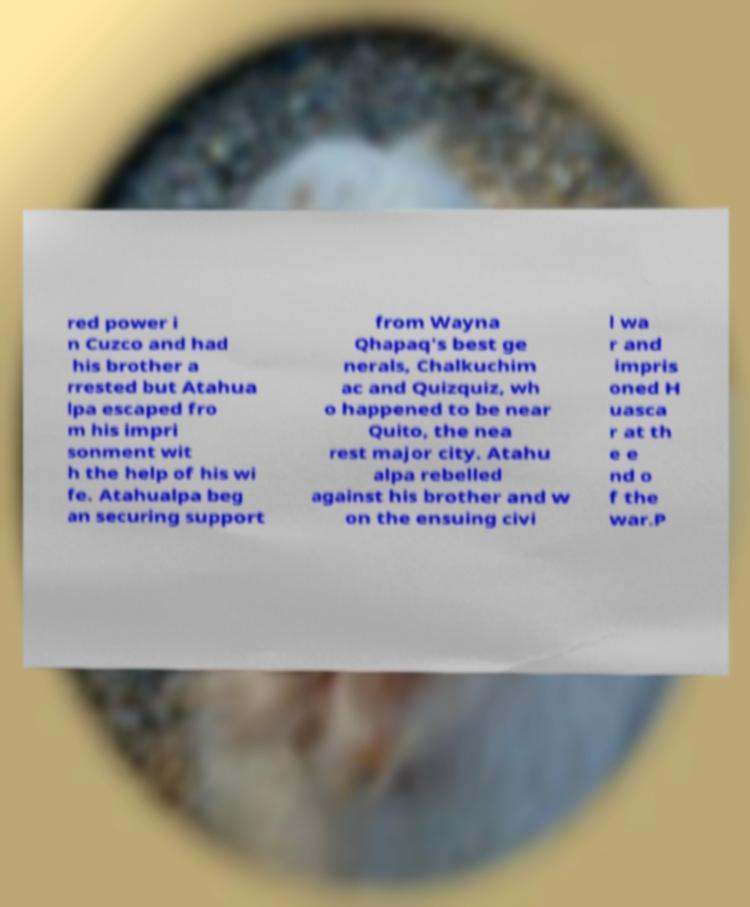Please identify and transcribe the text found in this image. red power i n Cuzco and had his brother a rrested but Atahua lpa escaped fro m his impri sonment wit h the help of his wi fe. Atahualpa beg an securing support from Wayna Qhapaq's best ge nerals, Chalkuchim ac and Quizquiz, wh o happened to be near Quito, the nea rest major city. Atahu alpa rebelled against his brother and w on the ensuing civi l wa r and impris oned H uasca r at th e e nd o f the war.P 